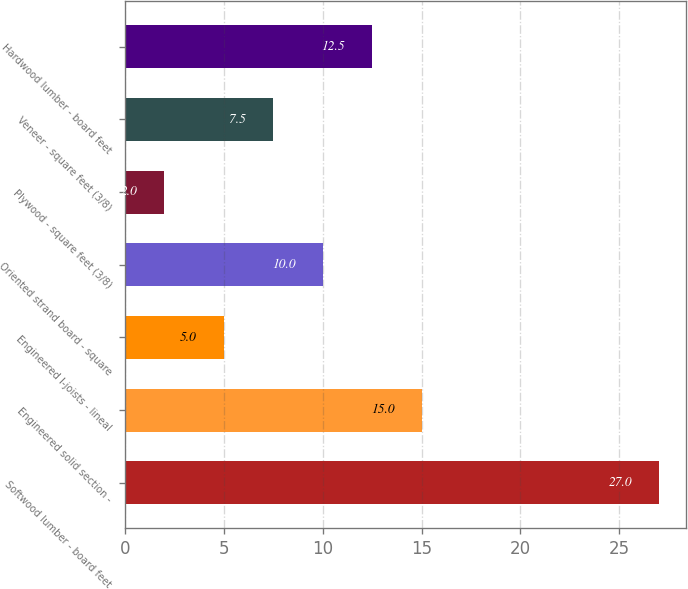Convert chart. <chart><loc_0><loc_0><loc_500><loc_500><bar_chart><fcel>Softwood lumber - board feet<fcel>Engineered solid section -<fcel>Engineered I-joists - lineal<fcel>Oriented strand board - square<fcel>Plywood - square feet (3/8)<fcel>Veneer - square feet (3/8)<fcel>Hardwood lumber - board feet<nl><fcel>27<fcel>15<fcel>5<fcel>10<fcel>2<fcel>7.5<fcel>12.5<nl></chart> 